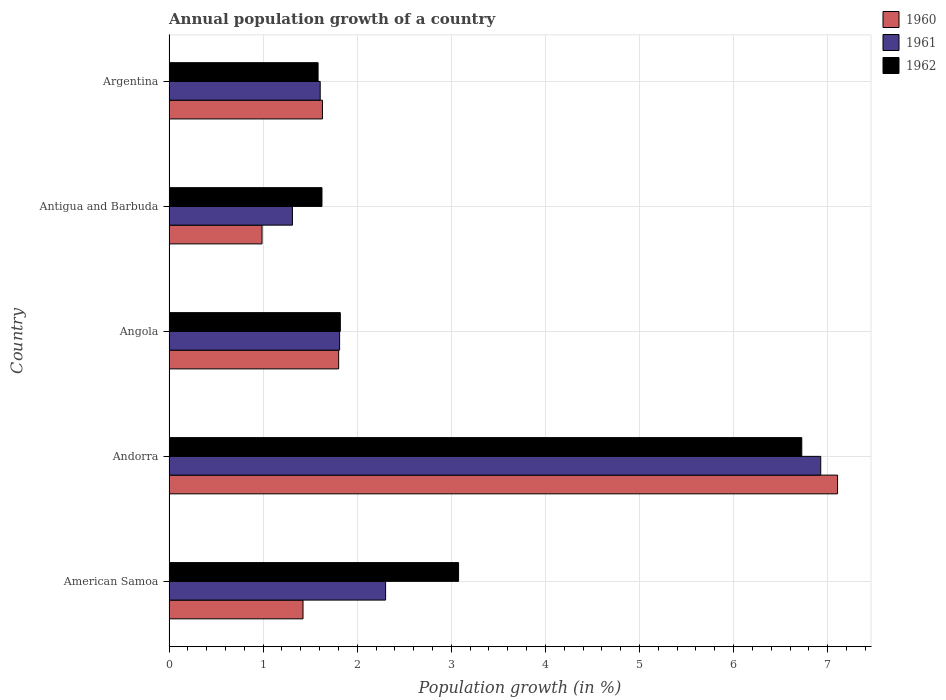How many groups of bars are there?
Your response must be concise. 5. Are the number of bars per tick equal to the number of legend labels?
Your answer should be compact. Yes. How many bars are there on the 2nd tick from the top?
Give a very brief answer. 3. What is the label of the 3rd group of bars from the top?
Your answer should be compact. Angola. In how many cases, is the number of bars for a given country not equal to the number of legend labels?
Keep it short and to the point. 0. What is the annual population growth in 1960 in Argentina?
Give a very brief answer. 1.63. Across all countries, what is the maximum annual population growth in 1961?
Make the answer very short. 6.93. Across all countries, what is the minimum annual population growth in 1960?
Ensure brevity in your answer.  0.99. In which country was the annual population growth in 1962 maximum?
Keep it short and to the point. Andorra. What is the total annual population growth in 1962 in the graph?
Your answer should be compact. 14.83. What is the difference between the annual population growth in 1960 in Angola and that in Antigua and Barbuda?
Your answer should be compact. 0.81. What is the difference between the annual population growth in 1960 in Antigua and Barbuda and the annual population growth in 1962 in Andorra?
Ensure brevity in your answer.  -5.74. What is the average annual population growth in 1960 per country?
Provide a succinct answer. 2.59. What is the difference between the annual population growth in 1961 and annual population growth in 1960 in American Samoa?
Offer a very short reply. 0.88. In how many countries, is the annual population growth in 1962 greater than 2.6 %?
Provide a succinct answer. 2. What is the ratio of the annual population growth in 1960 in Angola to that in Argentina?
Make the answer very short. 1.11. Is the annual population growth in 1962 in Andorra less than that in Argentina?
Your answer should be very brief. No. What is the difference between the highest and the second highest annual population growth in 1960?
Keep it short and to the point. 5.3. What is the difference between the highest and the lowest annual population growth in 1962?
Keep it short and to the point. 5.14. In how many countries, is the annual population growth in 1962 greater than the average annual population growth in 1962 taken over all countries?
Provide a short and direct response. 2. Is the sum of the annual population growth in 1962 in American Samoa and Andorra greater than the maximum annual population growth in 1960 across all countries?
Offer a very short reply. Yes. What does the 3rd bar from the top in American Samoa represents?
Make the answer very short. 1960. What does the 1st bar from the bottom in American Samoa represents?
Offer a very short reply. 1960. How many bars are there?
Provide a succinct answer. 15. Are all the bars in the graph horizontal?
Ensure brevity in your answer.  Yes. Does the graph contain any zero values?
Offer a terse response. No. What is the title of the graph?
Provide a succinct answer. Annual population growth of a country. What is the label or title of the X-axis?
Your answer should be very brief. Population growth (in %). What is the Population growth (in %) in 1960 in American Samoa?
Keep it short and to the point. 1.42. What is the Population growth (in %) of 1961 in American Samoa?
Keep it short and to the point. 2.3. What is the Population growth (in %) in 1962 in American Samoa?
Your response must be concise. 3.08. What is the Population growth (in %) of 1960 in Andorra?
Provide a short and direct response. 7.11. What is the Population growth (in %) in 1961 in Andorra?
Make the answer very short. 6.93. What is the Population growth (in %) of 1962 in Andorra?
Ensure brevity in your answer.  6.72. What is the Population growth (in %) of 1960 in Angola?
Provide a short and direct response. 1.8. What is the Population growth (in %) of 1961 in Angola?
Keep it short and to the point. 1.81. What is the Population growth (in %) of 1962 in Angola?
Offer a terse response. 1.82. What is the Population growth (in %) in 1960 in Antigua and Barbuda?
Your answer should be very brief. 0.99. What is the Population growth (in %) of 1961 in Antigua and Barbuda?
Give a very brief answer. 1.31. What is the Population growth (in %) in 1962 in Antigua and Barbuda?
Your response must be concise. 1.63. What is the Population growth (in %) in 1960 in Argentina?
Your answer should be compact. 1.63. What is the Population growth (in %) in 1961 in Argentina?
Provide a succinct answer. 1.61. What is the Population growth (in %) of 1962 in Argentina?
Ensure brevity in your answer.  1.58. Across all countries, what is the maximum Population growth (in %) in 1960?
Your response must be concise. 7.11. Across all countries, what is the maximum Population growth (in %) in 1961?
Your answer should be very brief. 6.93. Across all countries, what is the maximum Population growth (in %) of 1962?
Your answer should be compact. 6.72. Across all countries, what is the minimum Population growth (in %) of 1960?
Offer a very short reply. 0.99. Across all countries, what is the minimum Population growth (in %) in 1961?
Offer a very short reply. 1.31. Across all countries, what is the minimum Population growth (in %) in 1962?
Keep it short and to the point. 1.58. What is the total Population growth (in %) in 1960 in the graph?
Your answer should be compact. 12.95. What is the total Population growth (in %) in 1961 in the graph?
Offer a very short reply. 13.96. What is the total Population growth (in %) in 1962 in the graph?
Keep it short and to the point. 14.83. What is the difference between the Population growth (in %) of 1960 in American Samoa and that in Andorra?
Your answer should be compact. -5.68. What is the difference between the Population growth (in %) in 1961 in American Samoa and that in Andorra?
Keep it short and to the point. -4.62. What is the difference between the Population growth (in %) of 1962 in American Samoa and that in Andorra?
Your answer should be compact. -3.65. What is the difference between the Population growth (in %) of 1960 in American Samoa and that in Angola?
Make the answer very short. -0.38. What is the difference between the Population growth (in %) of 1961 in American Samoa and that in Angola?
Your response must be concise. 0.49. What is the difference between the Population growth (in %) of 1962 in American Samoa and that in Angola?
Your answer should be compact. 1.26. What is the difference between the Population growth (in %) of 1960 in American Samoa and that in Antigua and Barbuda?
Ensure brevity in your answer.  0.44. What is the difference between the Population growth (in %) of 1961 in American Samoa and that in Antigua and Barbuda?
Offer a terse response. 0.99. What is the difference between the Population growth (in %) of 1962 in American Samoa and that in Antigua and Barbuda?
Provide a succinct answer. 1.45. What is the difference between the Population growth (in %) of 1960 in American Samoa and that in Argentina?
Ensure brevity in your answer.  -0.21. What is the difference between the Population growth (in %) of 1961 in American Samoa and that in Argentina?
Your answer should be compact. 0.69. What is the difference between the Population growth (in %) of 1962 in American Samoa and that in Argentina?
Ensure brevity in your answer.  1.49. What is the difference between the Population growth (in %) of 1960 in Andorra and that in Angola?
Ensure brevity in your answer.  5.3. What is the difference between the Population growth (in %) in 1961 in Andorra and that in Angola?
Your answer should be very brief. 5.11. What is the difference between the Population growth (in %) in 1962 in Andorra and that in Angola?
Offer a very short reply. 4.9. What is the difference between the Population growth (in %) in 1960 in Andorra and that in Antigua and Barbuda?
Provide a succinct answer. 6.12. What is the difference between the Population growth (in %) in 1961 in Andorra and that in Antigua and Barbuda?
Offer a very short reply. 5.61. What is the difference between the Population growth (in %) in 1962 in Andorra and that in Antigua and Barbuda?
Provide a succinct answer. 5.1. What is the difference between the Population growth (in %) in 1960 in Andorra and that in Argentina?
Make the answer very short. 5.47. What is the difference between the Population growth (in %) in 1961 in Andorra and that in Argentina?
Make the answer very short. 5.32. What is the difference between the Population growth (in %) in 1962 in Andorra and that in Argentina?
Your answer should be very brief. 5.14. What is the difference between the Population growth (in %) in 1960 in Angola and that in Antigua and Barbuda?
Provide a succinct answer. 0.81. What is the difference between the Population growth (in %) of 1961 in Angola and that in Antigua and Barbuda?
Your answer should be compact. 0.5. What is the difference between the Population growth (in %) in 1962 in Angola and that in Antigua and Barbuda?
Keep it short and to the point. 0.2. What is the difference between the Population growth (in %) in 1960 in Angola and that in Argentina?
Offer a terse response. 0.17. What is the difference between the Population growth (in %) of 1961 in Angola and that in Argentina?
Your answer should be compact. 0.21. What is the difference between the Population growth (in %) in 1962 in Angola and that in Argentina?
Your response must be concise. 0.24. What is the difference between the Population growth (in %) of 1960 in Antigua and Barbuda and that in Argentina?
Give a very brief answer. -0.64. What is the difference between the Population growth (in %) in 1961 in Antigua and Barbuda and that in Argentina?
Offer a terse response. -0.3. What is the difference between the Population growth (in %) in 1962 in Antigua and Barbuda and that in Argentina?
Offer a very short reply. 0.04. What is the difference between the Population growth (in %) in 1960 in American Samoa and the Population growth (in %) in 1961 in Andorra?
Your response must be concise. -5.5. What is the difference between the Population growth (in %) of 1960 in American Samoa and the Population growth (in %) of 1962 in Andorra?
Keep it short and to the point. -5.3. What is the difference between the Population growth (in %) of 1961 in American Samoa and the Population growth (in %) of 1962 in Andorra?
Your answer should be very brief. -4.42. What is the difference between the Population growth (in %) in 1960 in American Samoa and the Population growth (in %) in 1961 in Angola?
Offer a terse response. -0.39. What is the difference between the Population growth (in %) of 1960 in American Samoa and the Population growth (in %) of 1962 in Angola?
Offer a terse response. -0.4. What is the difference between the Population growth (in %) in 1961 in American Samoa and the Population growth (in %) in 1962 in Angola?
Offer a terse response. 0.48. What is the difference between the Population growth (in %) in 1960 in American Samoa and the Population growth (in %) in 1961 in Antigua and Barbuda?
Make the answer very short. 0.11. What is the difference between the Population growth (in %) in 1960 in American Samoa and the Population growth (in %) in 1962 in Antigua and Barbuda?
Your answer should be very brief. -0.2. What is the difference between the Population growth (in %) in 1961 in American Samoa and the Population growth (in %) in 1962 in Antigua and Barbuda?
Offer a terse response. 0.68. What is the difference between the Population growth (in %) in 1960 in American Samoa and the Population growth (in %) in 1961 in Argentina?
Offer a terse response. -0.18. What is the difference between the Population growth (in %) of 1960 in American Samoa and the Population growth (in %) of 1962 in Argentina?
Provide a succinct answer. -0.16. What is the difference between the Population growth (in %) in 1961 in American Samoa and the Population growth (in %) in 1962 in Argentina?
Your response must be concise. 0.72. What is the difference between the Population growth (in %) of 1960 in Andorra and the Population growth (in %) of 1961 in Angola?
Your answer should be compact. 5.29. What is the difference between the Population growth (in %) in 1960 in Andorra and the Population growth (in %) in 1962 in Angola?
Ensure brevity in your answer.  5.28. What is the difference between the Population growth (in %) in 1961 in Andorra and the Population growth (in %) in 1962 in Angola?
Offer a very short reply. 5.11. What is the difference between the Population growth (in %) in 1960 in Andorra and the Population growth (in %) in 1961 in Antigua and Barbuda?
Provide a succinct answer. 5.79. What is the difference between the Population growth (in %) in 1960 in Andorra and the Population growth (in %) in 1962 in Antigua and Barbuda?
Provide a short and direct response. 5.48. What is the difference between the Population growth (in %) in 1961 in Andorra and the Population growth (in %) in 1962 in Antigua and Barbuda?
Your answer should be very brief. 5.3. What is the difference between the Population growth (in %) of 1960 in Andorra and the Population growth (in %) of 1961 in Argentina?
Provide a succinct answer. 5.5. What is the difference between the Population growth (in %) in 1960 in Andorra and the Population growth (in %) in 1962 in Argentina?
Keep it short and to the point. 5.52. What is the difference between the Population growth (in %) of 1961 in Andorra and the Population growth (in %) of 1962 in Argentina?
Offer a terse response. 5.34. What is the difference between the Population growth (in %) in 1960 in Angola and the Population growth (in %) in 1961 in Antigua and Barbuda?
Ensure brevity in your answer.  0.49. What is the difference between the Population growth (in %) in 1960 in Angola and the Population growth (in %) in 1962 in Antigua and Barbuda?
Offer a terse response. 0.18. What is the difference between the Population growth (in %) of 1961 in Angola and the Population growth (in %) of 1962 in Antigua and Barbuda?
Give a very brief answer. 0.19. What is the difference between the Population growth (in %) in 1960 in Angola and the Population growth (in %) in 1961 in Argentina?
Provide a succinct answer. 0.2. What is the difference between the Population growth (in %) in 1960 in Angola and the Population growth (in %) in 1962 in Argentina?
Offer a very short reply. 0.22. What is the difference between the Population growth (in %) in 1961 in Angola and the Population growth (in %) in 1962 in Argentina?
Make the answer very short. 0.23. What is the difference between the Population growth (in %) of 1960 in Antigua and Barbuda and the Population growth (in %) of 1961 in Argentina?
Offer a terse response. -0.62. What is the difference between the Population growth (in %) of 1960 in Antigua and Barbuda and the Population growth (in %) of 1962 in Argentina?
Your response must be concise. -0.6. What is the difference between the Population growth (in %) in 1961 in Antigua and Barbuda and the Population growth (in %) in 1962 in Argentina?
Your answer should be very brief. -0.27. What is the average Population growth (in %) of 1960 per country?
Your answer should be compact. 2.59. What is the average Population growth (in %) in 1961 per country?
Offer a very short reply. 2.79. What is the average Population growth (in %) in 1962 per country?
Your answer should be very brief. 2.97. What is the difference between the Population growth (in %) in 1960 and Population growth (in %) in 1961 in American Samoa?
Provide a short and direct response. -0.88. What is the difference between the Population growth (in %) in 1960 and Population growth (in %) in 1962 in American Samoa?
Your answer should be compact. -1.65. What is the difference between the Population growth (in %) in 1961 and Population growth (in %) in 1962 in American Samoa?
Your answer should be very brief. -0.78. What is the difference between the Population growth (in %) of 1960 and Population growth (in %) of 1961 in Andorra?
Provide a succinct answer. 0.18. What is the difference between the Population growth (in %) in 1960 and Population growth (in %) in 1962 in Andorra?
Offer a very short reply. 0.38. What is the difference between the Population growth (in %) in 1961 and Population growth (in %) in 1962 in Andorra?
Provide a succinct answer. 0.2. What is the difference between the Population growth (in %) of 1960 and Population growth (in %) of 1961 in Angola?
Keep it short and to the point. -0.01. What is the difference between the Population growth (in %) in 1960 and Population growth (in %) in 1962 in Angola?
Your answer should be compact. -0.02. What is the difference between the Population growth (in %) of 1961 and Population growth (in %) of 1962 in Angola?
Your answer should be very brief. -0.01. What is the difference between the Population growth (in %) of 1960 and Population growth (in %) of 1961 in Antigua and Barbuda?
Your answer should be very brief. -0.32. What is the difference between the Population growth (in %) in 1960 and Population growth (in %) in 1962 in Antigua and Barbuda?
Your answer should be compact. -0.64. What is the difference between the Population growth (in %) in 1961 and Population growth (in %) in 1962 in Antigua and Barbuda?
Keep it short and to the point. -0.31. What is the difference between the Population growth (in %) in 1960 and Population growth (in %) in 1961 in Argentina?
Your answer should be very brief. 0.02. What is the difference between the Population growth (in %) of 1960 and Population growth (in %) of 1962 in Argentina?
Ensure brevity in your answer.  0.05. What is the difference between the Population growth (in %) in 1961 and Population growth (in %) in 1962 in Argentina?
Keep it short and to the point. 0.02. What is the ratio of the Population growth (in %) in 1960 in American Samoa to that in Andorra?
Offer a very short reply. 0.2. What is the ratio of the Population growth (in %) in 1961 in American Samoa to that in Andorra?
Your answer should be compact. 0.33. What is the ratio of the Population growth (in %) of 1962 in American Samoa to that in Andorra?
Your answer should be compact. 0.46. What is the ratio of the Population growth (in %) in 1960 in American Samoa to that in Angola?
Your answer should be very brief. 0.79. What is the ratio of the Population growth (in %) in 1961 in American Samoa to that in Angola?
Keep it short and to the point. 1.27. What is the ratio of the Population growth (in %) of 1962 in American Samoa to that in Angola?
Your answer should be very brief. 1.69. What is the ratio of the Population growth (in %) in 1960 in American Samoa to that in Antigua and Barbuda?
Keep it short and to the point. 1.44. What is the ratio of the Population growth (in %) of 1961 in American Samoa to that in Antigua and Barbuda?
Your response must be concise. 1.75. What is the ratio of the Population growth (in %) in 1962 in American Samoa to that in Antigua and Barbuda?
Give a very brief answer. 1.89. What is the ratio of the Population growth (in %) of 1960 in American Samoa to that in Argentina?
Ensure brevity in your answer.  0.87. What is the ratio of the Population growth (in %) of 1961 in American Samoa to that in Argentina?
Give a very brief answer. 1.43. What is the ratio of the Population growth (in %) in 1962 in American Samoa to that in Argentina?
Make the answer very short. 1.94. What is the ratio of the Population growth (in %) of 1960 in Andorra to that in Angola?
Give a very brief answer. 3.94. What is the ratio of the Population growth (in %) of 1961 in Andorra to that in Angola?
Make the answer very short. 3.82. What is the ratio of the Population growth (in %) of 1962 in Andorra to that in Angola?
Your response must be concise. 3.69. What is the ratio of the Population growth (in %) of 1960 in Andorra to that in Antigua and Barbuda?
Give a very brief answer. 7.19. What is the ratio of the Population growth (in %) in 1961 in Andorra to that in Antigua and Barbuda?
Provide a short and direct response. 5.28. What is the ratio of the Population growth (in %) of 1962 in Andorra to that in Antigua and Barbuda?
Offer a very short reply. 4.14. What is the ratio of the Population growth (in %) in 1960 in Andorra to that in Argentina?
Keep it short and to the point. 4.36. What is the ratio of the Population growth (in %) of 1961 in Andorra to that in Argentina?
Provide a short and direct response. 4.31. What is the ratio of the Population growth (in %) in 1962 in Andorra to that in Argentina?
Ensure brevity in your answer.  4.24. What is the ratio of the Population growth (in %) of 1960 in Angola to that in Antigua and Barbuda?
Your answer should be very brief. 1.82. What is the ratio of the Population growth (in %) of 1961 in Angola to that in Antigua and Barbuda?
Ensure brevity in your answer.  1.38. What is the ratio of the Population growth (in %) in 1962 in Angola to that in Antigua and Barbuda?
Provide a succinct answer. 1.12. What is the ratio of the Population growth (in %) in 1960 in Angola to that in Argentina?
Your answer should be very brief. 1.11. What is the ratio of the Population growth (in %) in 1961 in Angola to that in Argentina?
Your answer should be compact. 1.13. What is the ratio of the Population growth (in %) in 1962 in Angola to that in Argentina?
Keep it short and to the point. 1.15. What is the ratio of the Population growth (in %) in 1960 in Antigua and Barbuda to that in Argentina?
Keep it short and to the point. 0.61. What is the ratio of the Population growth (in %) in 1961 in Antigua and Barbuda to that in Argentina?
Keep it short and to the point. 0.82. What is the ratio of the Population growth (in %) of 1962 in Antigua and Barbuda to that in Argentina?
Provide a succinct answer. 1.03. What is the difference between the highest and the second highest Population growth (in %) of 1960?
Ensure brevity in your answer.  5.3. What is the difference between the highest and the second highest Population growth (in %) in 1961?
Offer a very short reply. 4.62. What is the difference between the highest and the second highest Population growth (in %) in 1962?
Ensure brevity in your answer.  3.65. What is the difference between the highest and the lowest Population growth (in %) of 1960?
Your response must be concise. 6.12. What is the difference between the highest and the lowest Population growth (in %) of 1961?
Keep it short and to the point. 5.61. What is the difference between the highest and the lowest Population growth (in %) in 1962?
Offer a terse response. 5.14. 